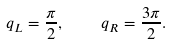<formula> <loc_0><loc_0><loc_500><loc_500>q _ { L } = \frac { \pi } { 2 } , \quad q _ { R } = \frac { 3 \pi } { 2 } .</formula> 